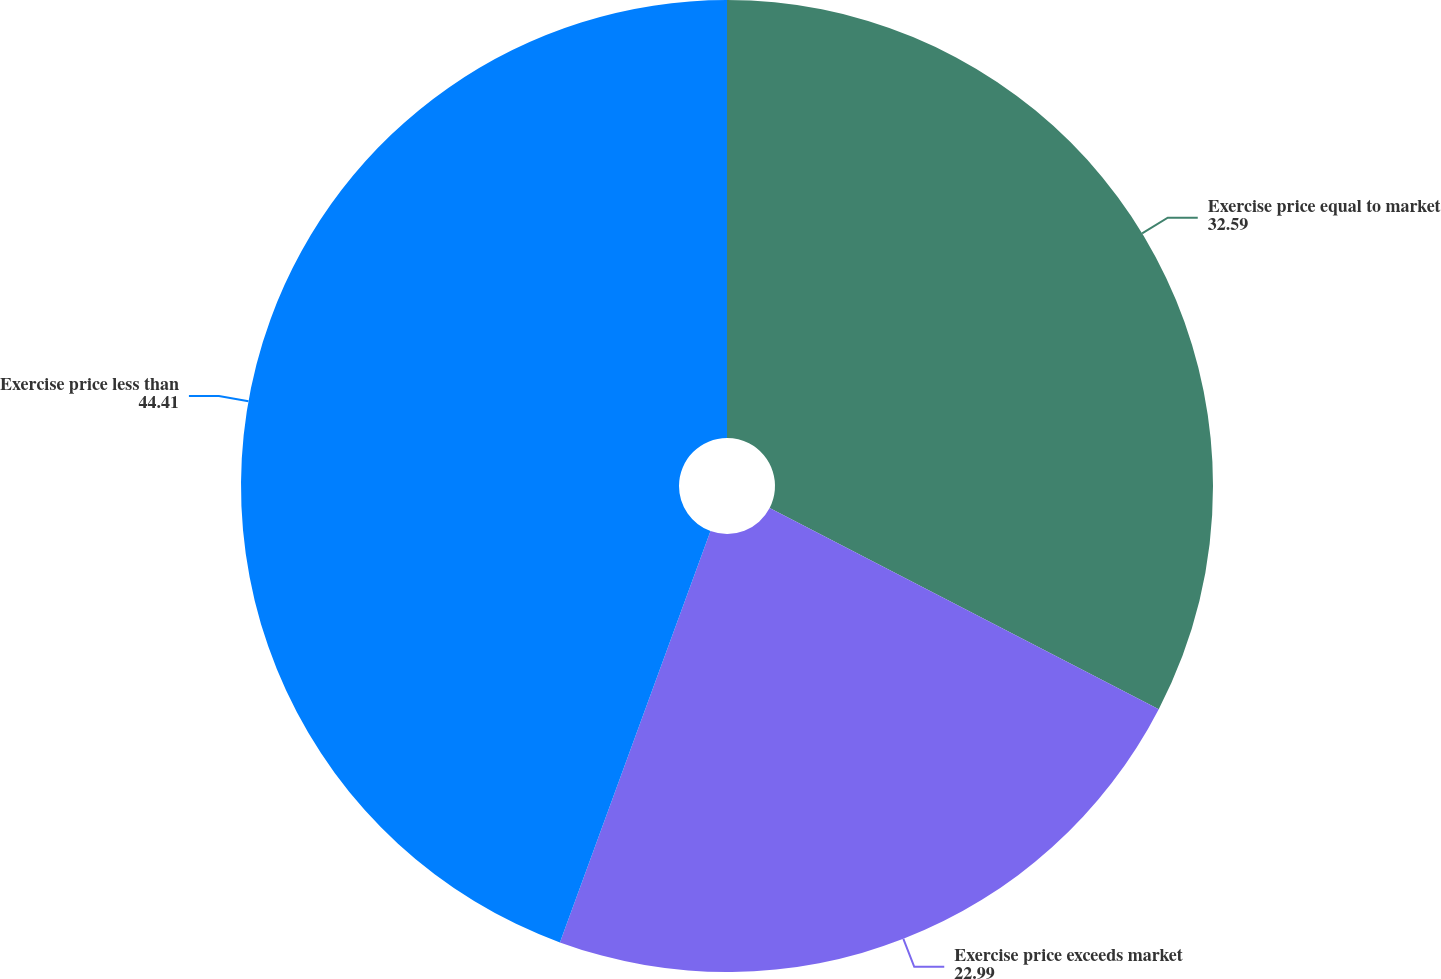Convert chart to OTSL. <chart><loc_0><loc_0><loc_500><loc_500><pie_chart><fcel>Exercise price equal to market<fcel>Exercise price exceeds market<fcel>Exercise price less than<nl><fcel>32.59%<fcel>22.99%<fcel>44.41%<nl></chart> 